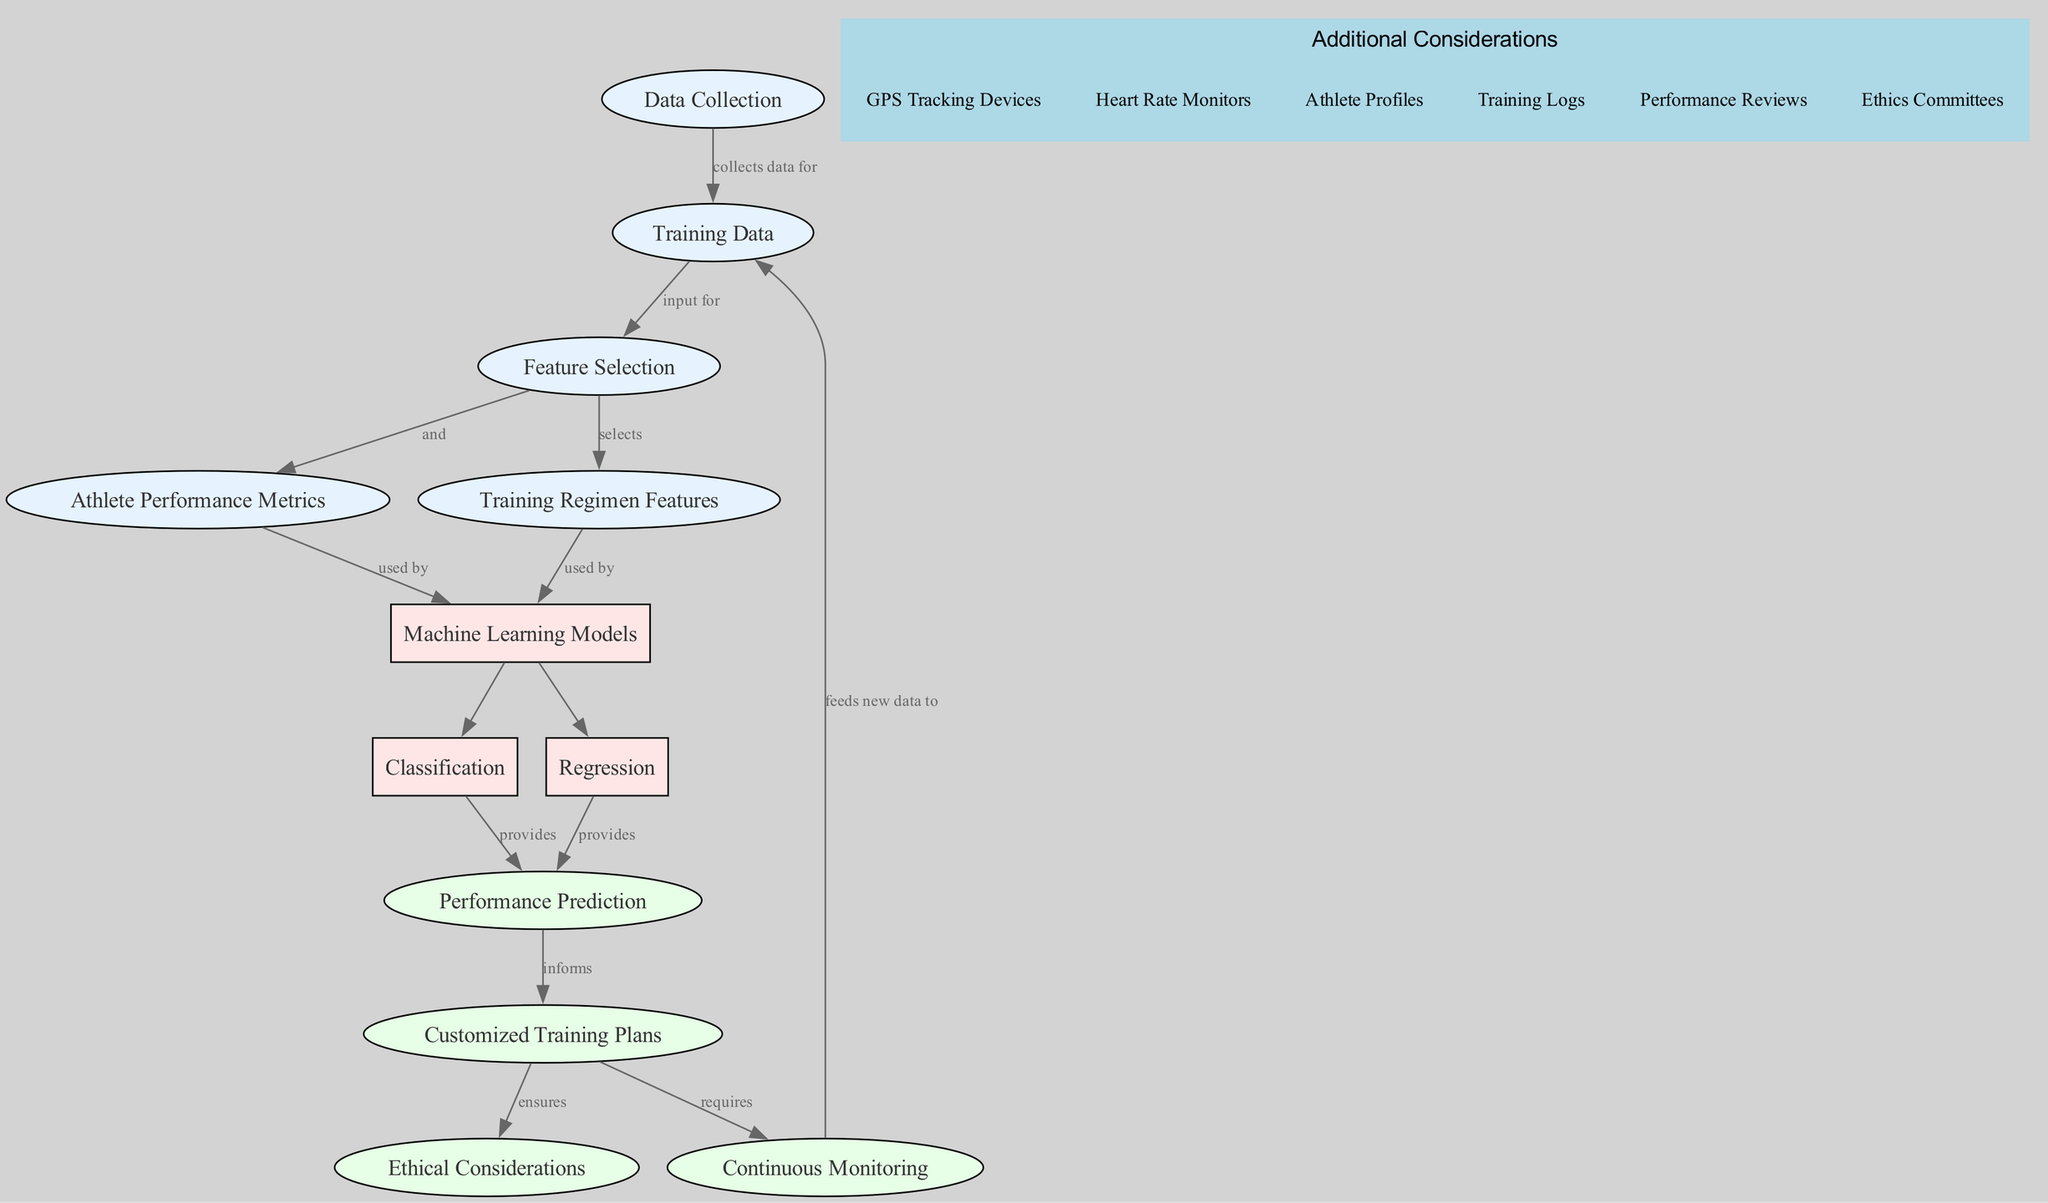What is the starting point of the diagram? The starting point is the "Data Collection" node, which collects data for further processing in the machine learning workflow.
Answer: Data Collection How many nodes are in the diagram? By counting the nodes listed in the data section, we see there are 12 nodes in total that represent various aspects of the machine learning process regarding player performance enhancement.
Answer: 12 What type of data is selected in the feature selection step? The "Training Regimen Features" and "Athlete Performance Metrics" are selected during the feature selection step according to the connections from the "Training Data" node.
Answer: Training Regimen Features, Athlete Performance Metrics Which machine learning models are utilized in this diagram? The diagram indicates that both Regression and Classification models are used in the machine learning process to analyze athlete performances.
Answer: Regression, Classification What does the Performance Prediction node inform? The Performance Prediction node informs the Customized Training Plans, indicating its role in producing insights that guide personalized training strategies.
Answer: Customized Training Plans What ensures the ethical considerations in this diagram? The "Customized Training Plans" node explicitly connects to the "Ethical Considerations" node, indicating an assurance of ethical practices in the development and implementation of training plans.
Answer: Ethical Considerations How is continuous monitoring integrated into the workflow? Continuous monitoring feeds new data back to the "Training Data" node, thereby creating an iterative loop that helps refine and improve training plans based on updated performance metrics.
Answer: Feeds new data to Training Data What are some examples of additional considerations mentioned in the diagram? Examples of additional considerations include GPS Tracking Devices, Heart Rate Monitors, Athlete Profiles, Training Logs, Performance Reviews, and Ethics Committees, which are relevant to the diagram's context.
Answer: GPS Tracking Devices, Heart Rate Monitors, Athlete Profiles, Training Logs, Performance Reviews, Ethics Committees 